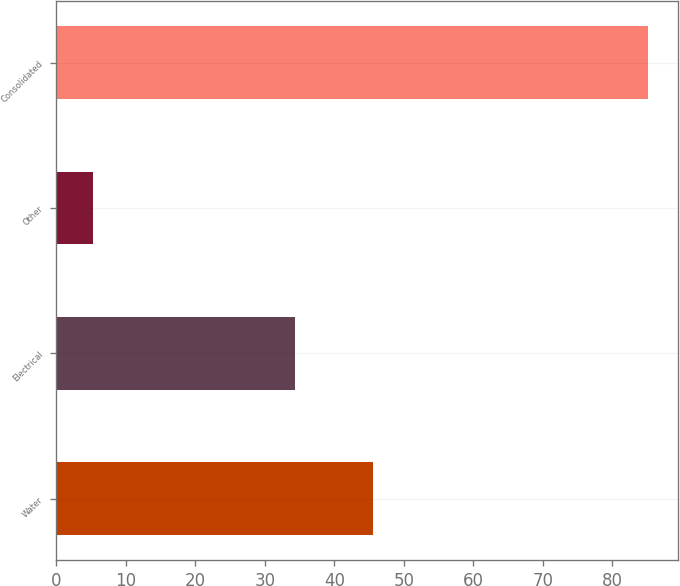Convert chart to OTSL. <chart><loc_0><loc_0><loc_500><loc_500><bar_chart><fcel>Water<fcel>Electrical<fcel>Other<fcel>Consolidated<nl><fcel>45.6<fcel>34.3<fcel>5.3<fcel>85.2<nl></chart> 